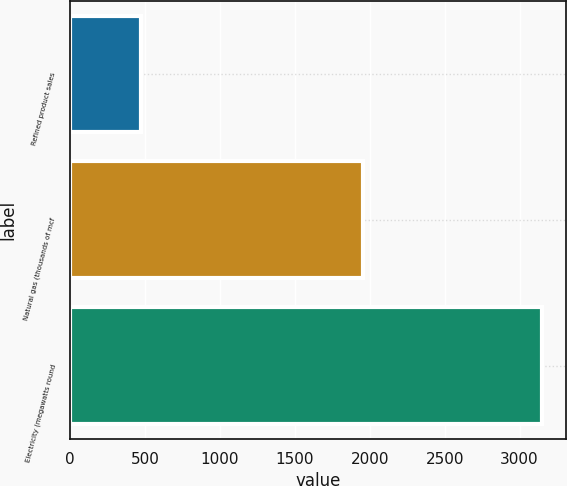Convert chart. <chart><loc_0><loc_0><loc_500><loc_500><bar_chart><fcel>Refined product sales<fcel>Natural gas (thousands of mcf<fcel>Electricity (megawatts round<nl><fcel>472<fcel>1955<fcel>3152<nl></chart> 